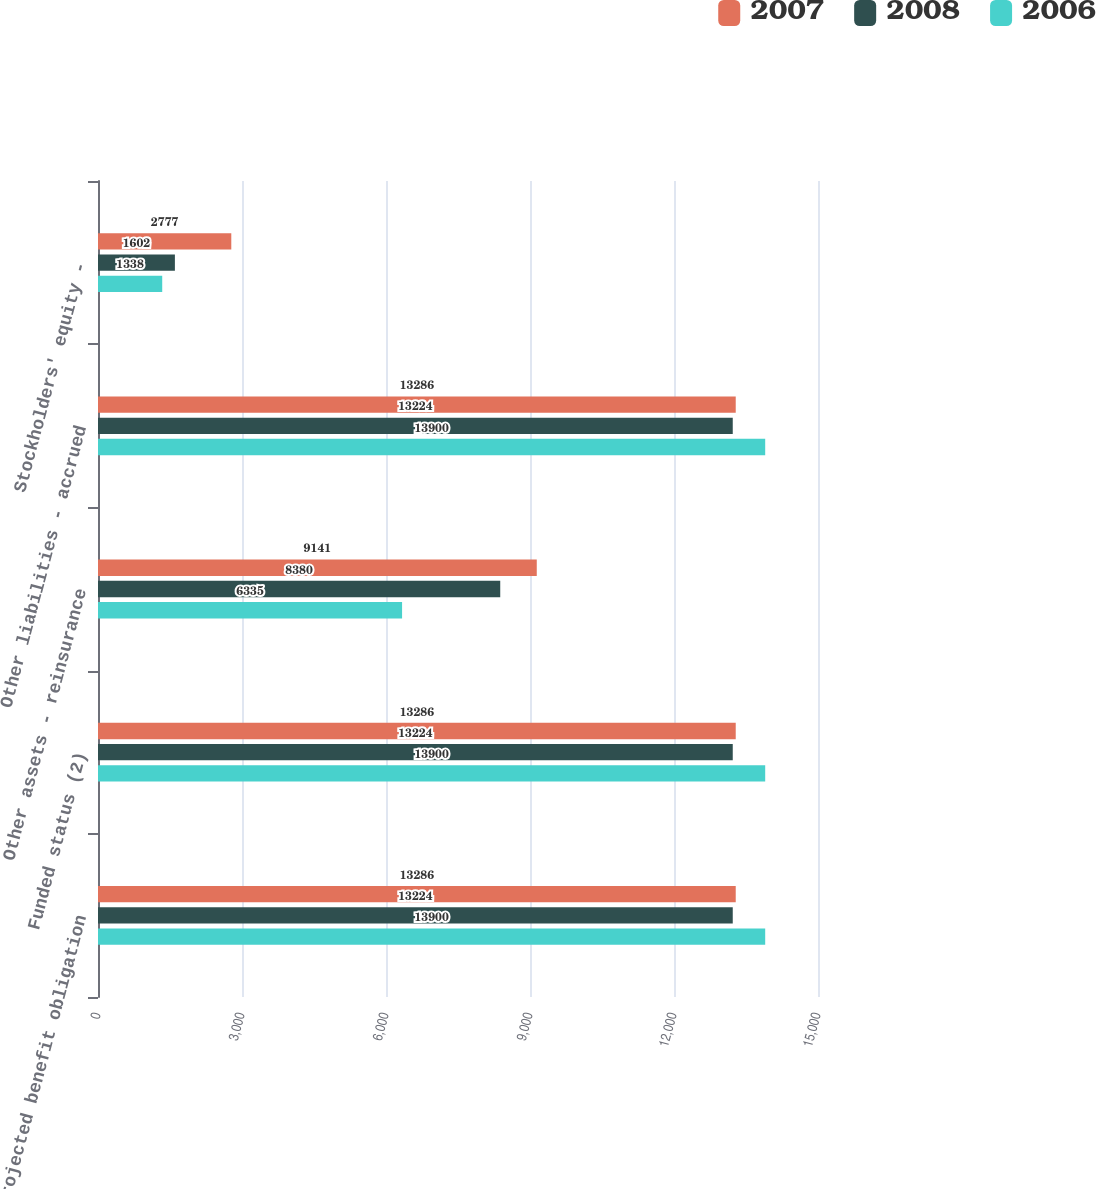<chart> <loc_0><loc_0><loc_500><loc_500><stacked_bar_chart><ecel><fcel>Projected benefit obligation<fcel>Funded status (2)<fcel>Other assets - reinsurance<fcel>Other liabilities - accrued<fcel>Stockholders' equity -<nl><fcel>2007<fcel>13286<fcel>13286<fcel>9141<fcel>13286<fcel>2777<nl><fcel>2008<fcel>13224<fcel>13224<fcel>8380<fcel>13224<fcel>1602<nl><fcel>2006<fcel>13900<fcel>13900<fcel>6335<fcel>13900<fcel>1338<nl></chart> 